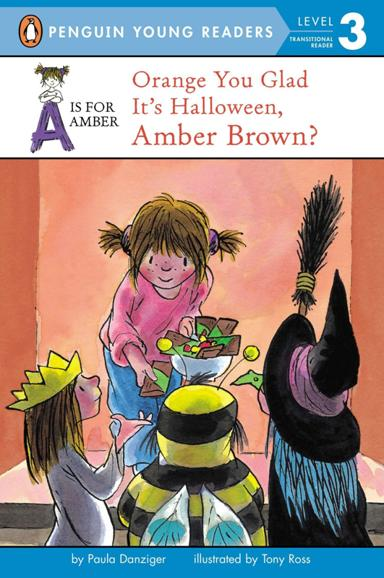What is the reading level indicated in the image? The book falls under Level 3 of the Penguin Young Readers series, making it an excellent choice for developing readers who are transitioning to more complex texts. This level supports children in enhancing their reading fluency and comprehension. 